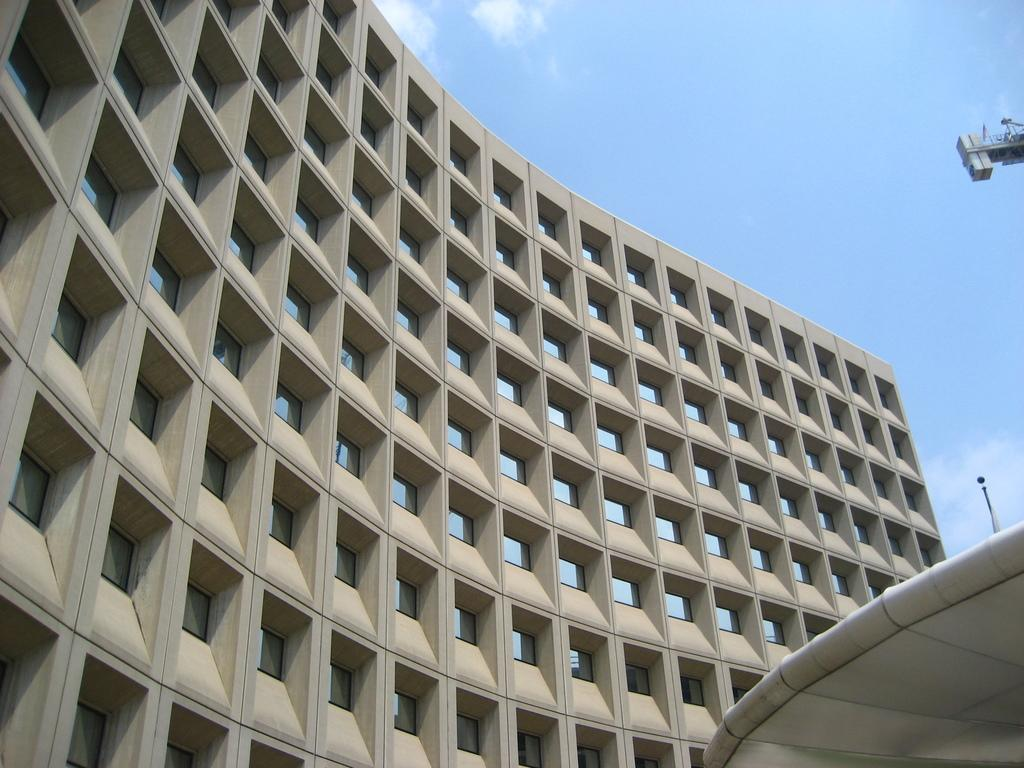What type of structure is present in the image? There is a building in the image. How would you describe the sky in the image? The sky is blue and cloudy. Can you identify any machinery or equipment in the image? Yes, there is a crane visible in the image. What type of apple is being pulled by the army in the image? There is no army or apple present in the image. 